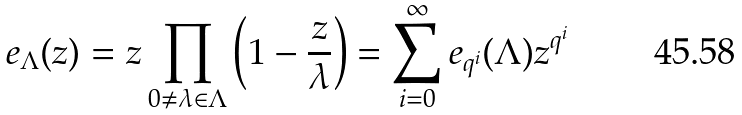Convert formula to latex. <formula><loc_0><loc_0><loc_500><loc_500>e _ { \Lambda } ( z ) = z \prod _ { 0 \neq \lambda \in \Lambda } \left ( 1 - \frac { z } { \lambda } \right ) = \sum _ { i = 0 } ^ { \infty } e _ { q ^ { i } } ( \Lambda ) z ^ { q ^ { i } }</formula> 